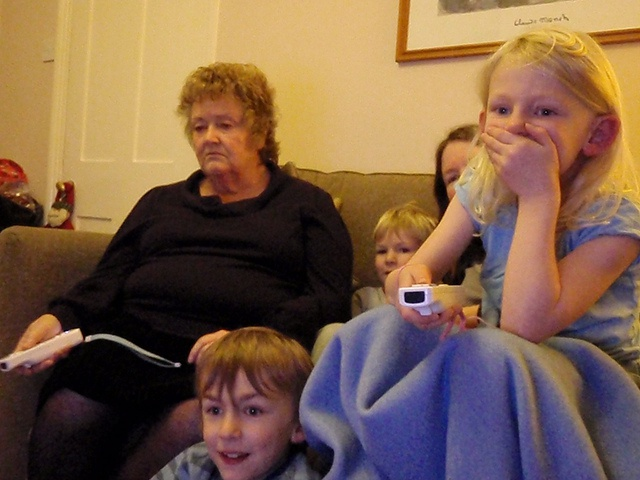Describe the objects in this image and their specific colors. I can see people in tan, brown, purple, and gray tones, people in tan, black, brown, and maroon tones, people in tan, maroon, brown, and black tones, couch in tan, maroon, olive, and black tones, and people in tan, olive, gray, and maroon tones in this image. 